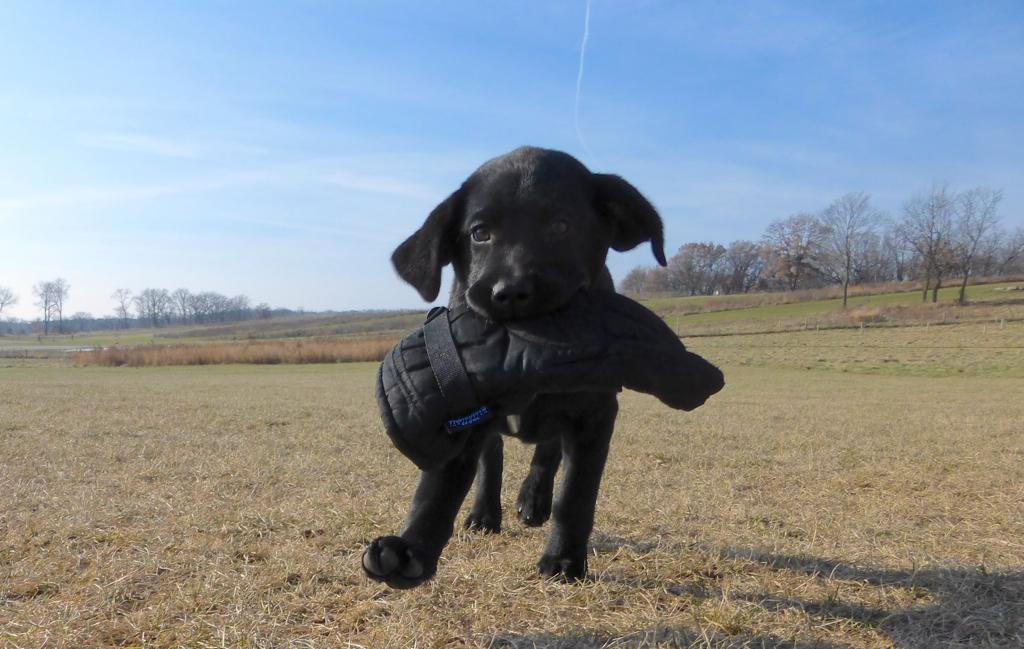What type of animal is in the image? There is a black dog in the image. What is the dog standing on? The dog is on dry grass. What can be seen on both sides of the image? There are trees on the right side and the left side of the image. What color is the sky in the image? The sky is blue in color. What advice does the potato give to the dog in the image? There is no potato present in the image, and therefore no advice can be given. 